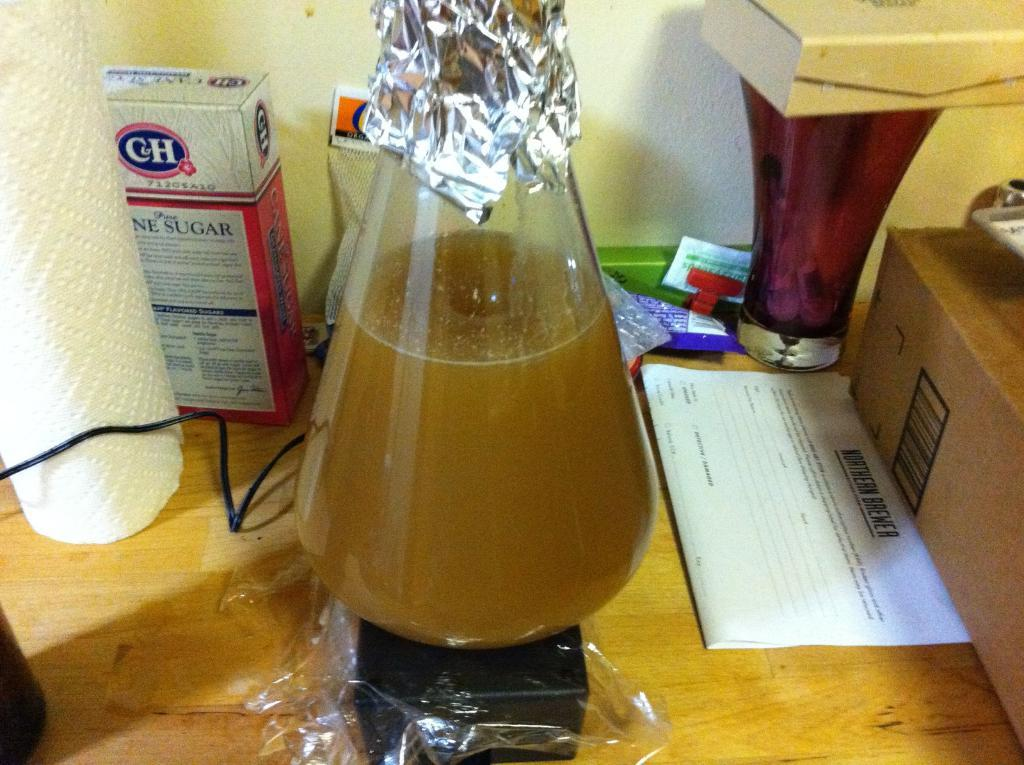<image>
Create a compact narrative representing the image presented. a beaker filled with a box of sugar behind it 